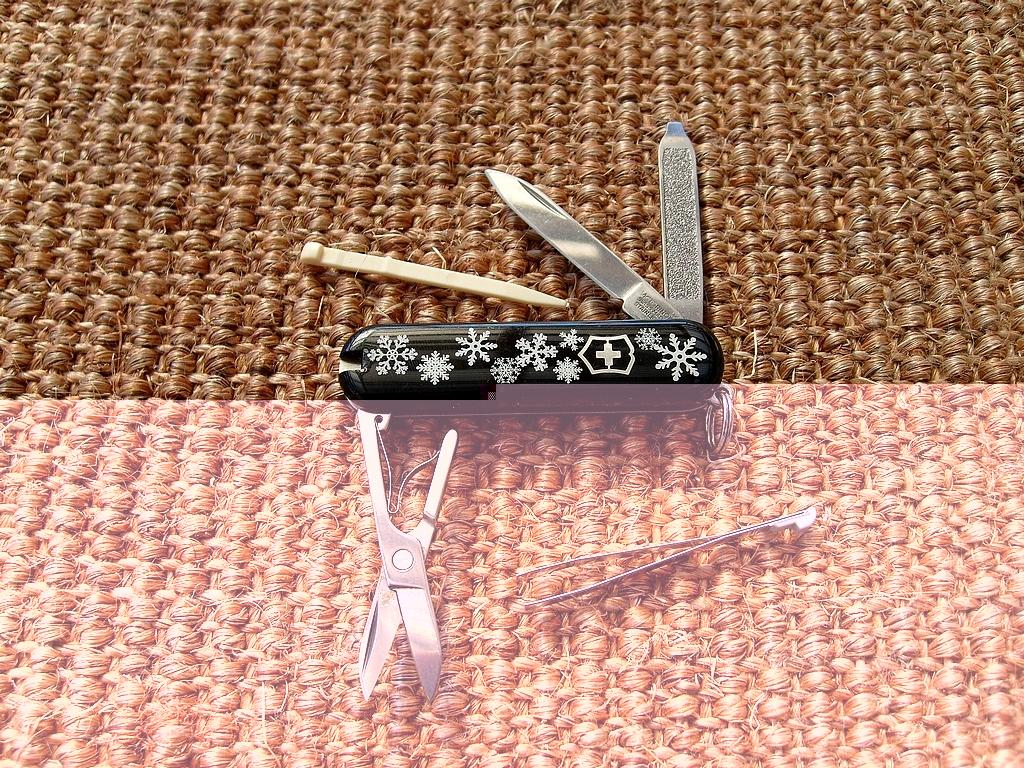What is the color of the object that has the black multi-tool on it? The object with the black multi-tool on it is brown. What is the color of the other object mentioned in the image? The other object mentioned in the image is cream-colored. Can you describe the unspecified object in the image? Unfortunately, there is not enough information provided to describe the unspecified object in the image. Is there a stream flowing near the brown object in the image? There is no mention of a stream in the provided facts, so it cannot be determined if there is one near the brown object in the image. 